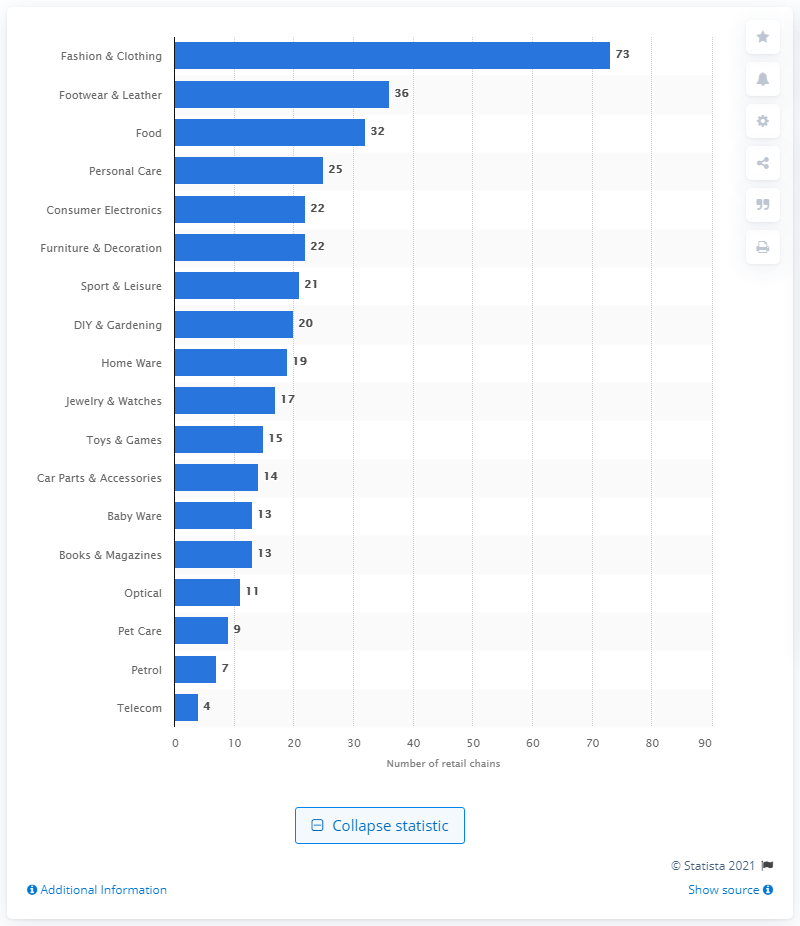Mention a couple of crucial points in this snapshot. There were 32 chains in the food sector in Italy in 2019. 